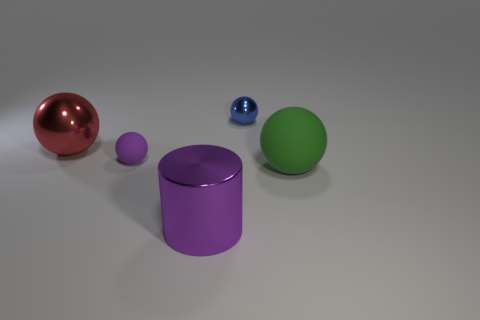Add 3 big green things. How many objects exist? 8 Subtract all cylinders. How many objects are left? 4 Add 4 small things. How many small things are left? 6 Add 2 cylinders. How many cylinders exist? 3 Subtract 1 red balls. How many objects are left? 4 Subtract all tiny matte balls. Subtract all small objects. How many objects are left? 2 